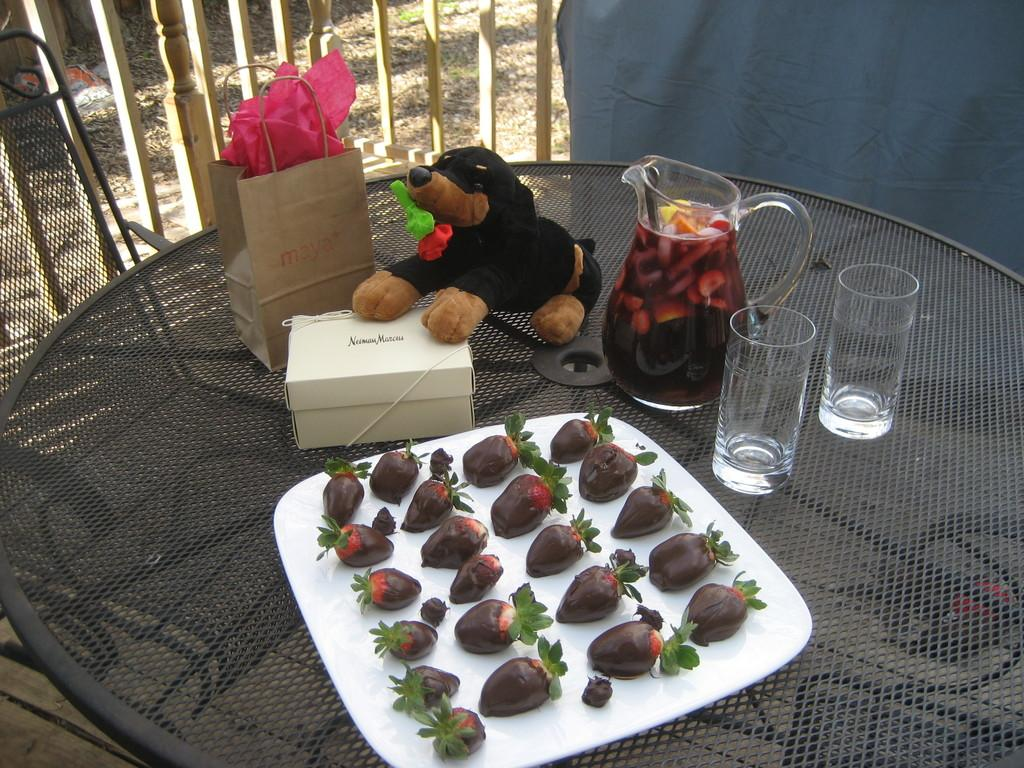What is the main object in the center of the image? There is a table in the center of the image. What can be found on the table? There are food items, glasses, a mug, a box, a paper cover, a cloth, and a dog doll on the table. Can you describe the background of the image? There is a chair, grass, and a sheet in the background. What type of vein is visible on the dog doll in the image? There are no veins visible on the dog doll in the image, as it is a doll and not a living creature. What type of paper is covering the table in the image? The provided facts do not specify the type of paper covering the table; it is simply described as a "paper cover." 